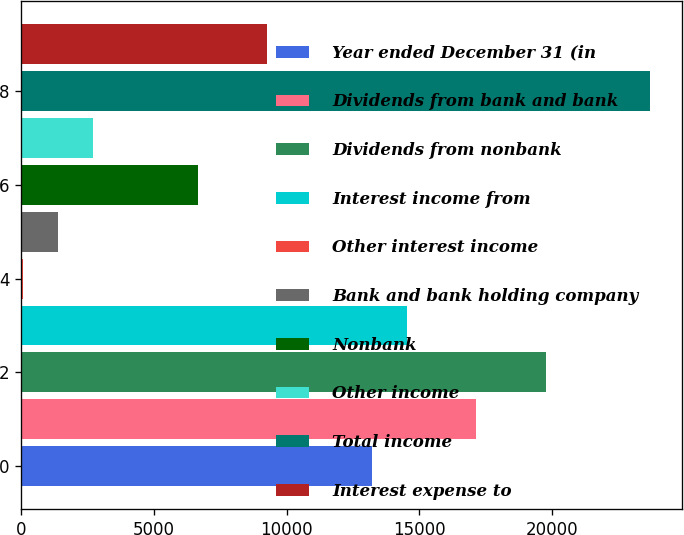Convert chart. <chart><loc_0><loc_0><loc_500><loc_500><bar_chart><fcel>Year ended December 31 (in<fcel>Dividends from bank and bank<fcel>Dividends from nonbank<fcel>Interest income from<fcel>Other interest income<fcel>Bank and bank holding company<fcel>Nonbank<fcel>Other income<fcel>Total income<fcel>Interest expense to<nl><fcel>13207<fcel>17148.1<fcel>19775.5<fcel>14520.7<fcel>70<fcel>1383.7<fcel>6638.5<fcel>2697.4<fcel>23716.6<fcel>9265.9<nl></chart> 